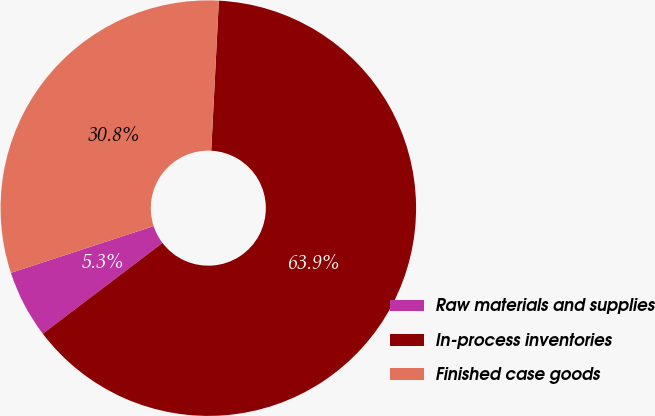<chart> <loc_0><loc_0><loc_500><loc_500><pie_chart><fcel>Raw materials and supplies<fcel>In-process inventories<fcel>Finished case goods<nl><fcel>5.29%<fcel>63.87%<fcel>30.85%<nl></chart> 